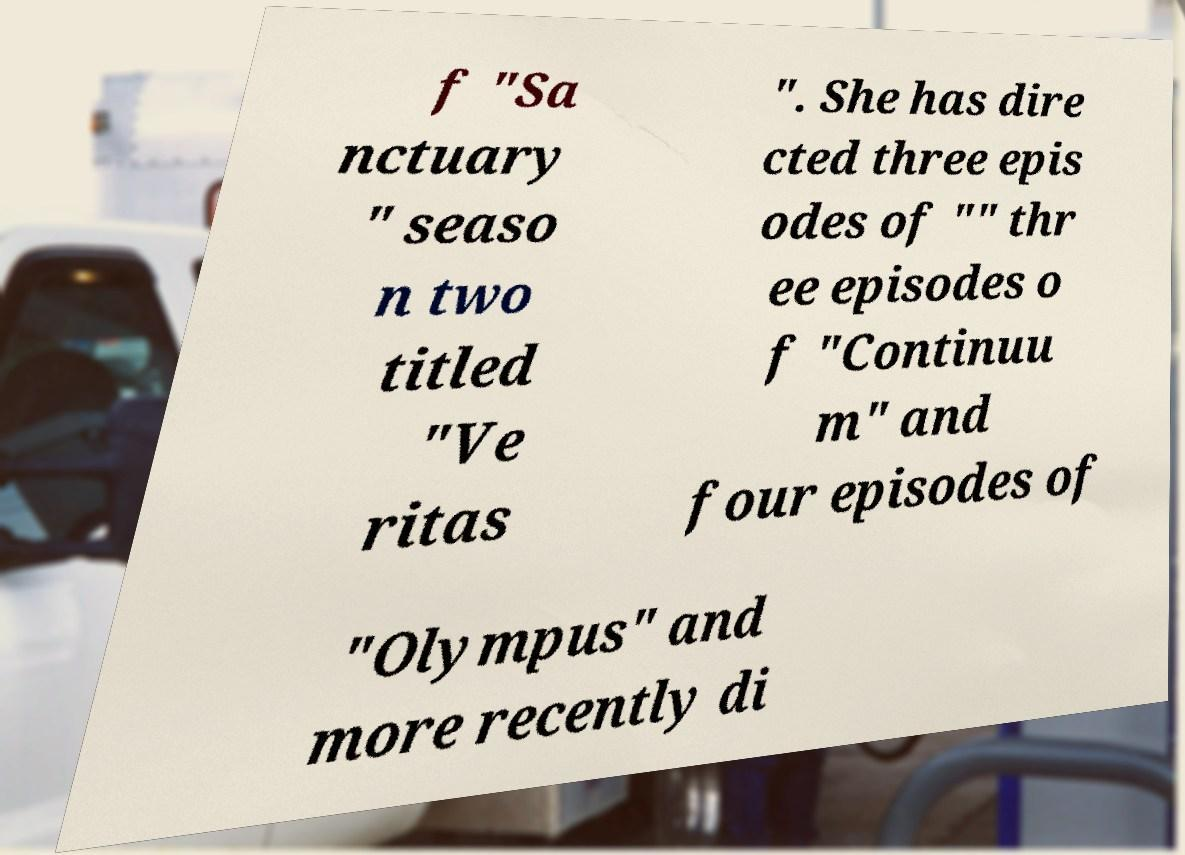What messages or text are displayed in this image? I need them in a readable, typed format. f "Sa nctuary " seaso n two titled "Ve ritas ". She has dire cted three epis odes of "" thr ee episodes o f "Continuu m" and four episodes of "Olympus" and more recently di 